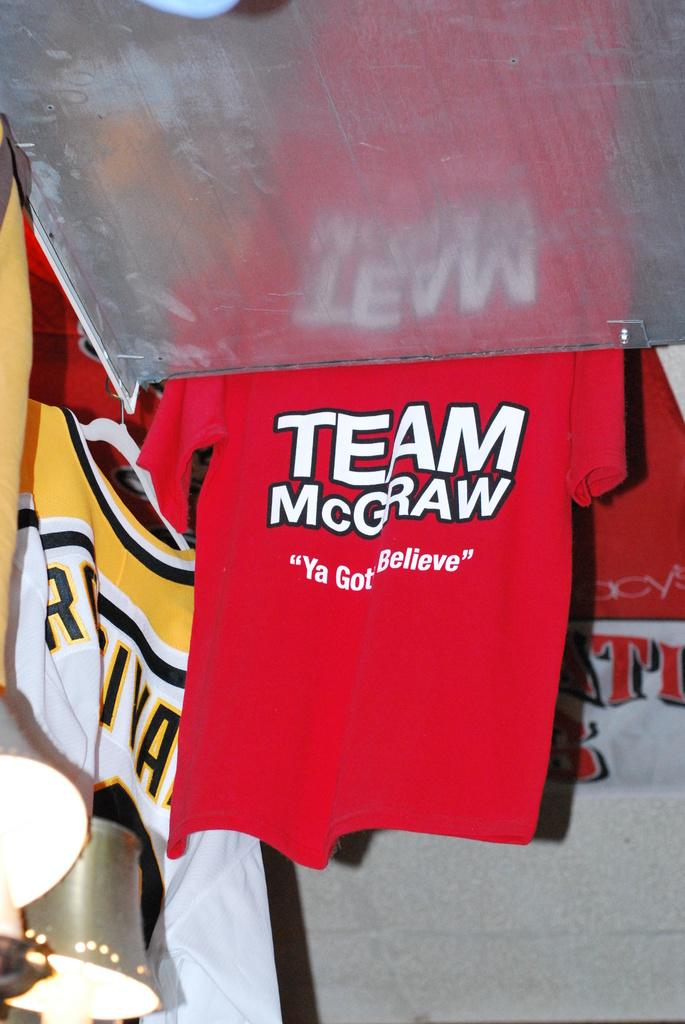<image>
Provide a brief description of the given image. A Team McGraw shirt says that we have to believe. 